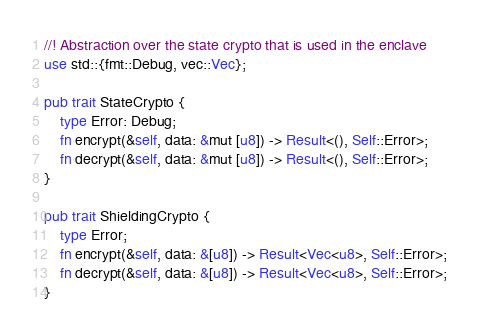Convert code to text. <code><loc_0><loc_0><loc_500><loc_500><_Rust_>//! Abstraction over the state crypto that is used in the enclave
use std::{fmt::Debug, vec::Vec};

pub trait StateCrypto {
	type Error: Debug;
	fn encrypt(&self, data: &mut [u8]) -> Result<(), Self::Error>;
	fn decrypt(&self, data: &mut [u8]) -> Result<(), Self::Error>;
}

pub trait ShieldingCrypto {
	type Error;
	fn encrypt(&self, data: &[u8]) -> Result<Vec<u8>, Self::Error>;
	fn decrypt(&self, data: &[u8]) -> Result<Vec<u8>, Self::Error>;
}
</code> 